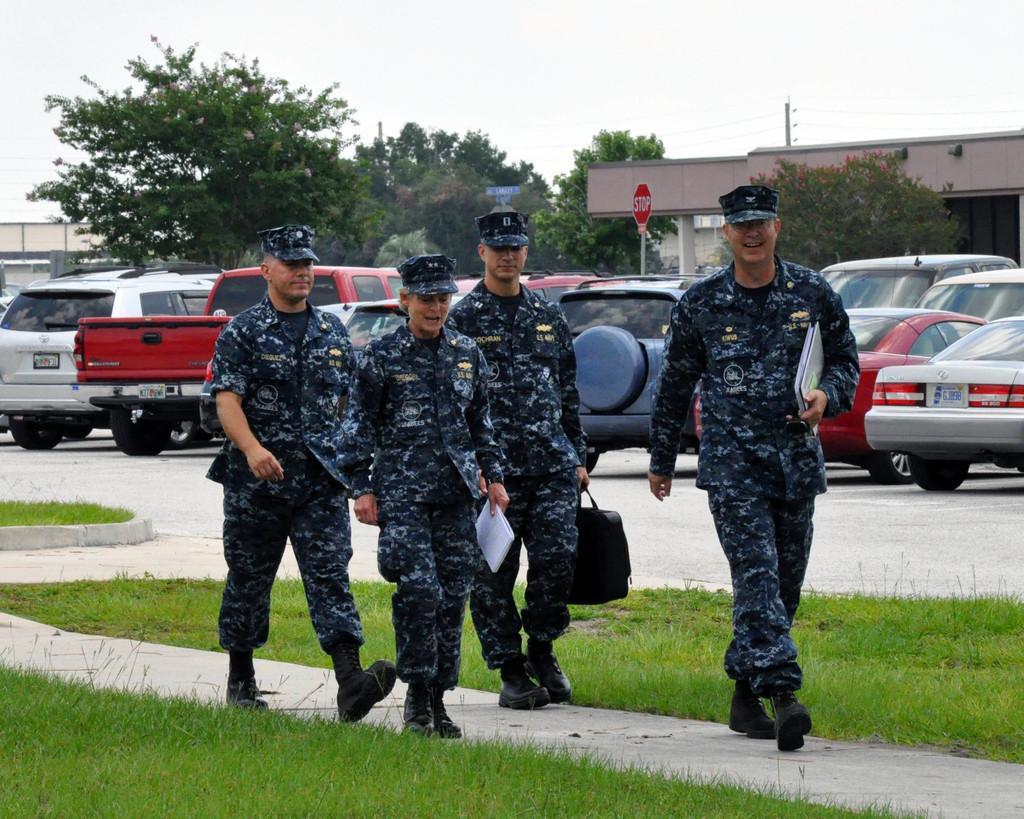Could you give a brief overview of what you see in this image? In the image we can see there are people walking, they are wearing army clothes, cap and some of them are carrying bags and books. Here we can see grass, path and trees. We can even see there are vehicles, electric poles, electric wires and the sky. 